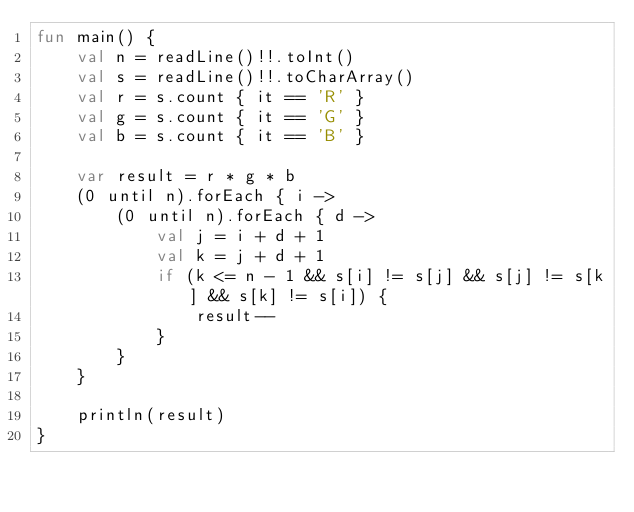<code> <loc_0><loc_0><loc_500><loc_500><_Kotlin_>fun main() {
    val n = readLine()!!.toInt()
    val s = readLine()!!.toCharArray()
    val r = s.count { it == 'R' }
    val g = s.count { it == 'G' }
    val b = s.count { it == 'B' }

    var result = r * g * b
    (0 until n).forEach { i ->
        (0 until n).forEach { d ->
            val j = i + d + 1
            val k = j + d + 1
            if (k <= n - 1 && s[i] != s[j] && s[j] != s[k] && s[k] != s[i]) {
                result--
            }
        }
    }

    println(result)
}</code> 